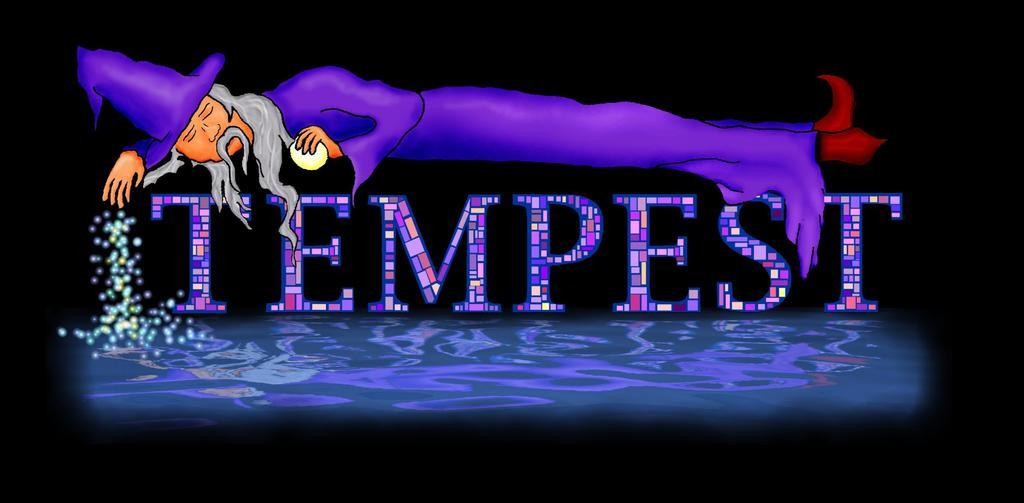What is located in the middle of the image? There is some text in the middle of the image. What can be seen at the bottom of the image? There is water at the bottom of the image. Where is the person in the image? The person is lying at the top of the image. What color is the hand holding the paintbrush in the image? There is no hand or paintbrush present in the image. What type of book is the person reading at the top of the image? There is no book present in the image; the person is lying at the top of the image. 